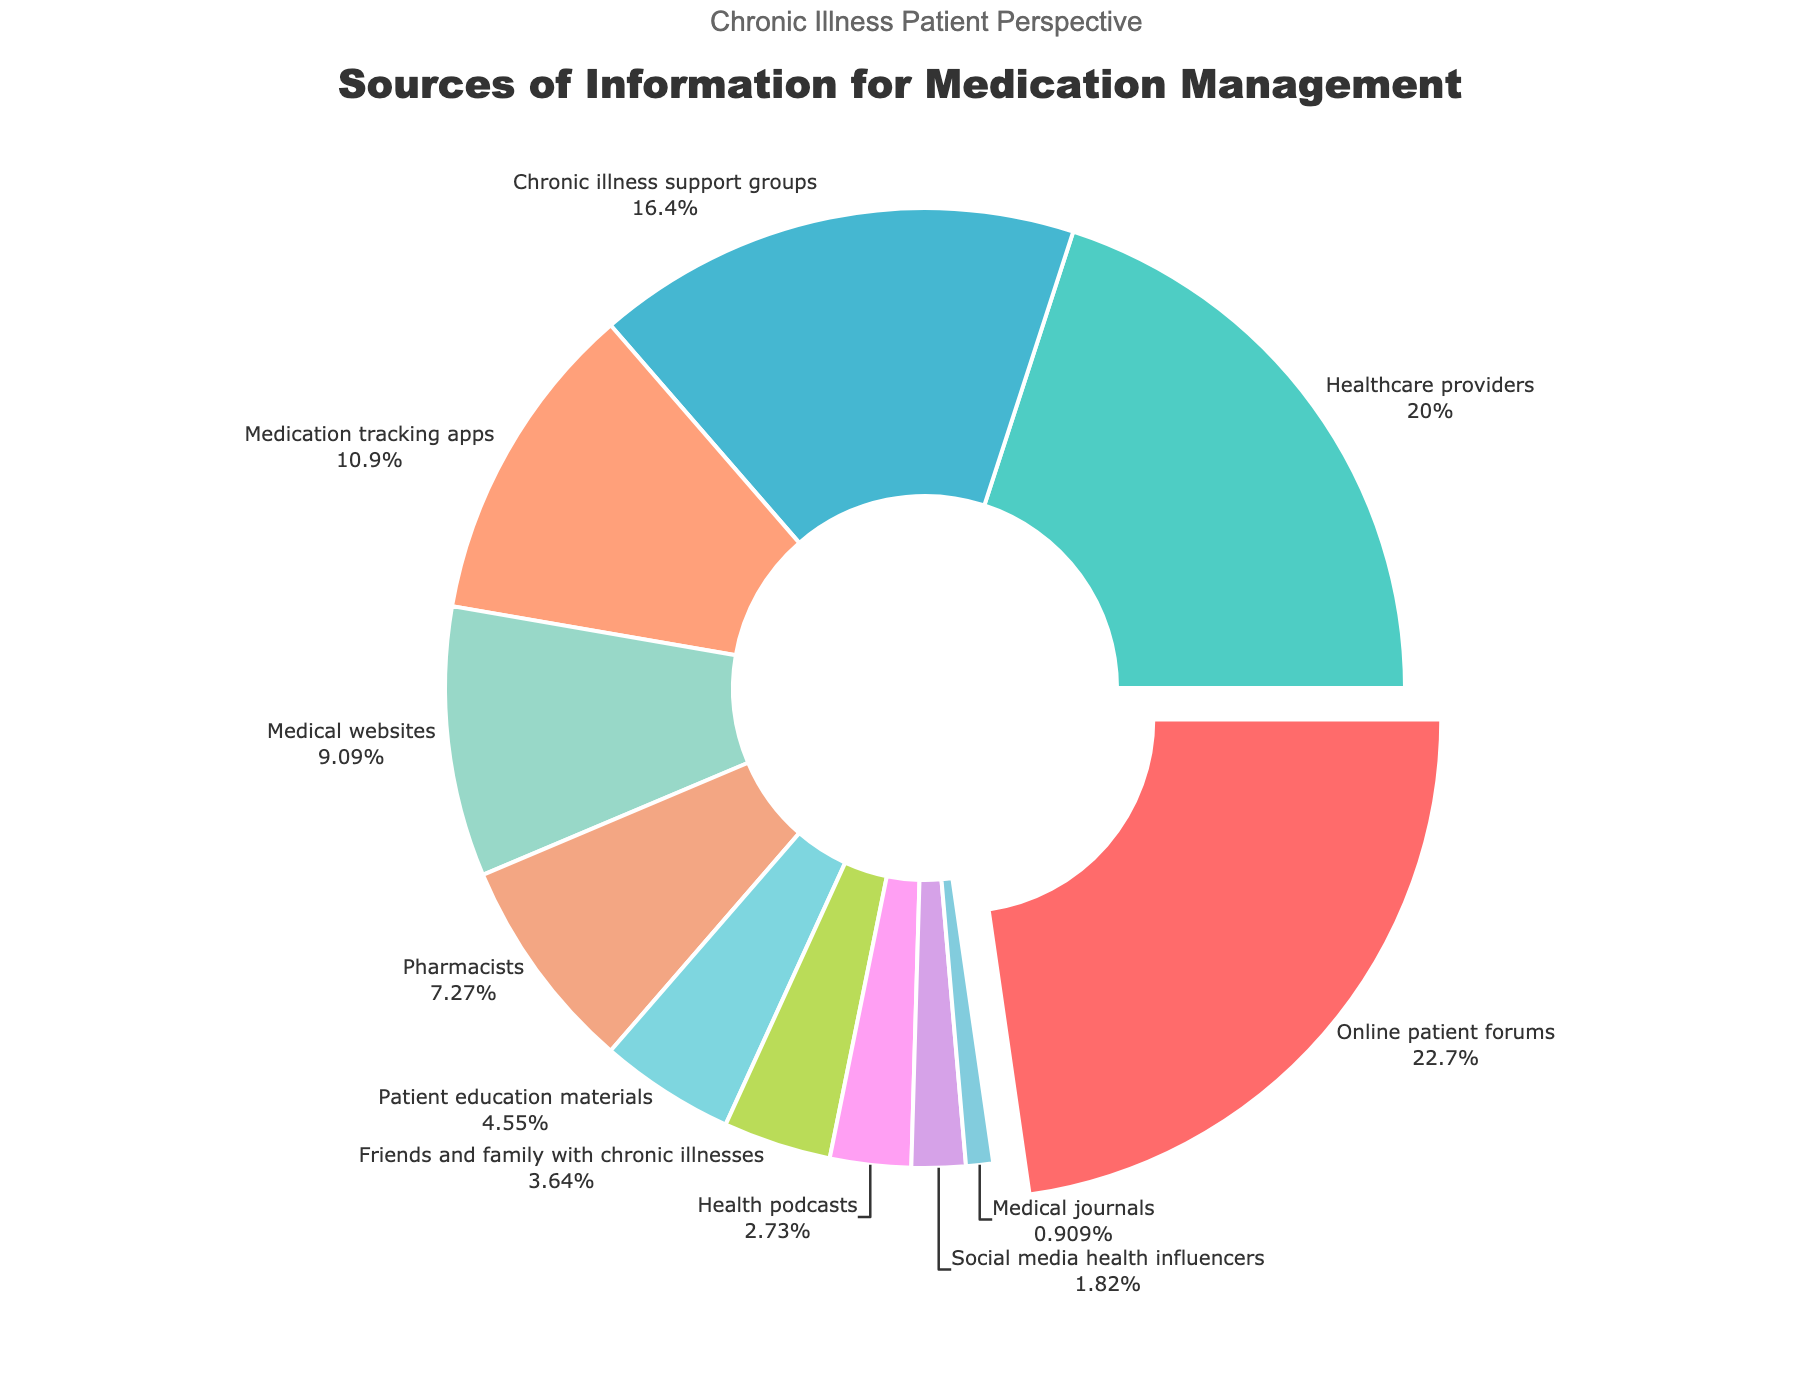which source has the largest percentage for information about medication management? The pie chart shows different sources and their corresponding percentages. The largest percentage slice appears for "Online patient forums" at 25%.
Answer: Online patient forums Which source has the least percentage? By looking at the smallest slice in the pie chart, we see that "Medical journals" has the smallest percentage at 1%.
Answer: Medical journals What is the combined percentage of 'Healthcare providers' and 'Pharmacists'? Add the percentages for 'Healthcare providers' (22%) and 'Pharmacists' (8%). The combined percentage is 22% + 8% = 30%.
Answer: 30% Which source is used more for information: 'Medical websites' or 'Medication tracking apps'? Comparing the sizes of the slices, 'Medication tracking apps' (12%) is larger than 'Medical websites' (10%), indicating it is used more.
Answer: Medication tracking apps By how much does the percentage for 'Chronic illness support groups' surpass that of 'Friends and family with chronic illnesses'? Subtract the percentage of 'Friends and family with chronic illnesses' (4%) from 'Chronic illness support groups' (18%). The difference is 18% - 4% = 14%.
Answer: 14% How many sources have a percentage greater than 10%? By examining the pie chart, we can count the slices: 'Online patient forums' (25%), 'Healthcare providers' (22%), 'Chronic illness support groups' (18%), and 'Medication tracking apps' (12%). This makes 4 sources.
Answer: 4 What is the average percentage of the top 3 sources? The top 3 sources and their percentages are 'Online patient forums' (25%), 'Healthcare providers' (22%), and 'Chronic illness support groups' (18%). The average is (25 + 22 + 18)/3 = 21.67%.
Answer: 21.67% Are 'Health podcasts' more popular than 'Social media health influencers' for information? Looking at the chart, 'Health podcasts' (3%) have a larger slice than 'Social media health influencers' (2%). Therefore, 'Health podcasts' are more popular.
Answer: Health podcasts What percentage do the sources with less than 5% each collectively contribute? Sum the percentages of sources with less than 5%: 'Patient education materials' (5%) + 'Friends and family with chronic illnesses' (4%) + 'Health podcasts' (3%) + 'Social media health influencers' (2%) + 'Medical journals' (1%). The total is 5% + 4% + 3% + 2% + 1% = 15%.
Answer: 15% What is the total percentage contribution of all sources listed in the pie chart? Each slice represents part of the whole pie chart, which sums up to 100%. All sources collectively contribute 100%.
Answer: 100% 